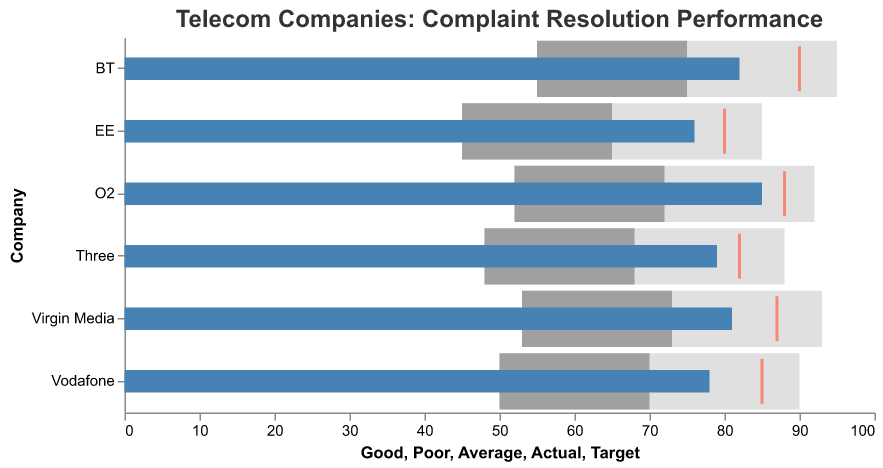What is the title of the figure? The title of the figure is displayed at the top and describes what the chart is about.
Answer: Telecom Companies: Complaint Resolution Performance How many telecom companies are shown in the figure? Count the number of unique company names listed along the y-axis.
Answer: Six Which telecom company has the highest actual percentage of consumer complaints resolved within the specified time frame? Check the blue bar that extends the farthest to the right for the actual percentage.
Answer: O2 How does BT's actual percentage compare to its target percentage? Compare the position of the blue bar (Actual) and the red tick mark (Target) for BT.
Answer: BT's actual percentage (82%) is below its target (90%) Is there any company that met or exceeded its target percentage for resolving complaints? Look for instances where the blue bar (Actual) meets or exceeds the red tick mark (Target).
Answer: O2 Which companies have an actual percentage within the "Good" range? Check if the blue bar (Actual) is within the "Good" range for each company, marked by the grey background extending to the farthest right.
Answer: Vodafone, BT, O2, Three, Virgin Media Between Vodafone and EE, which company has a better actual performance for resolving complaints? Compare the lengths of the blue bars (Actual) for Vodafone and EE.
Answer: Vodafone (78%) has better actual performance than EE (76%) How many companies have their actual performance below their respective average ranges? Count the companies where the blue bar (Actual) falls to the left of their defined "Average" range (middle grey bar).
Answer: Four (Vodafone, BT, EE, Virgin Media) What is the average difference between the actual performance and the target performance across all companies? Calculate the difference between actual and target for each company, sum up these differences, and then divide by the number of companies. The differences are Vodafone (-7), BT (-8), EE (-4), O2 (-3), Three (-3), Virgin Media (-6). Average = (-7 + -8 + -4 + -3 + -3 + -6) / 6 = -31 / 6.
Answer: -5.17 Are all companies' actual performances within the "Average" or "Good" ranges? Check if any blue bars (Actual) are outside the "Average" and "Good" ranges, denoted by the grey background areas.
Answer: Yes, all companies are within "Average" or "Good" ranges 